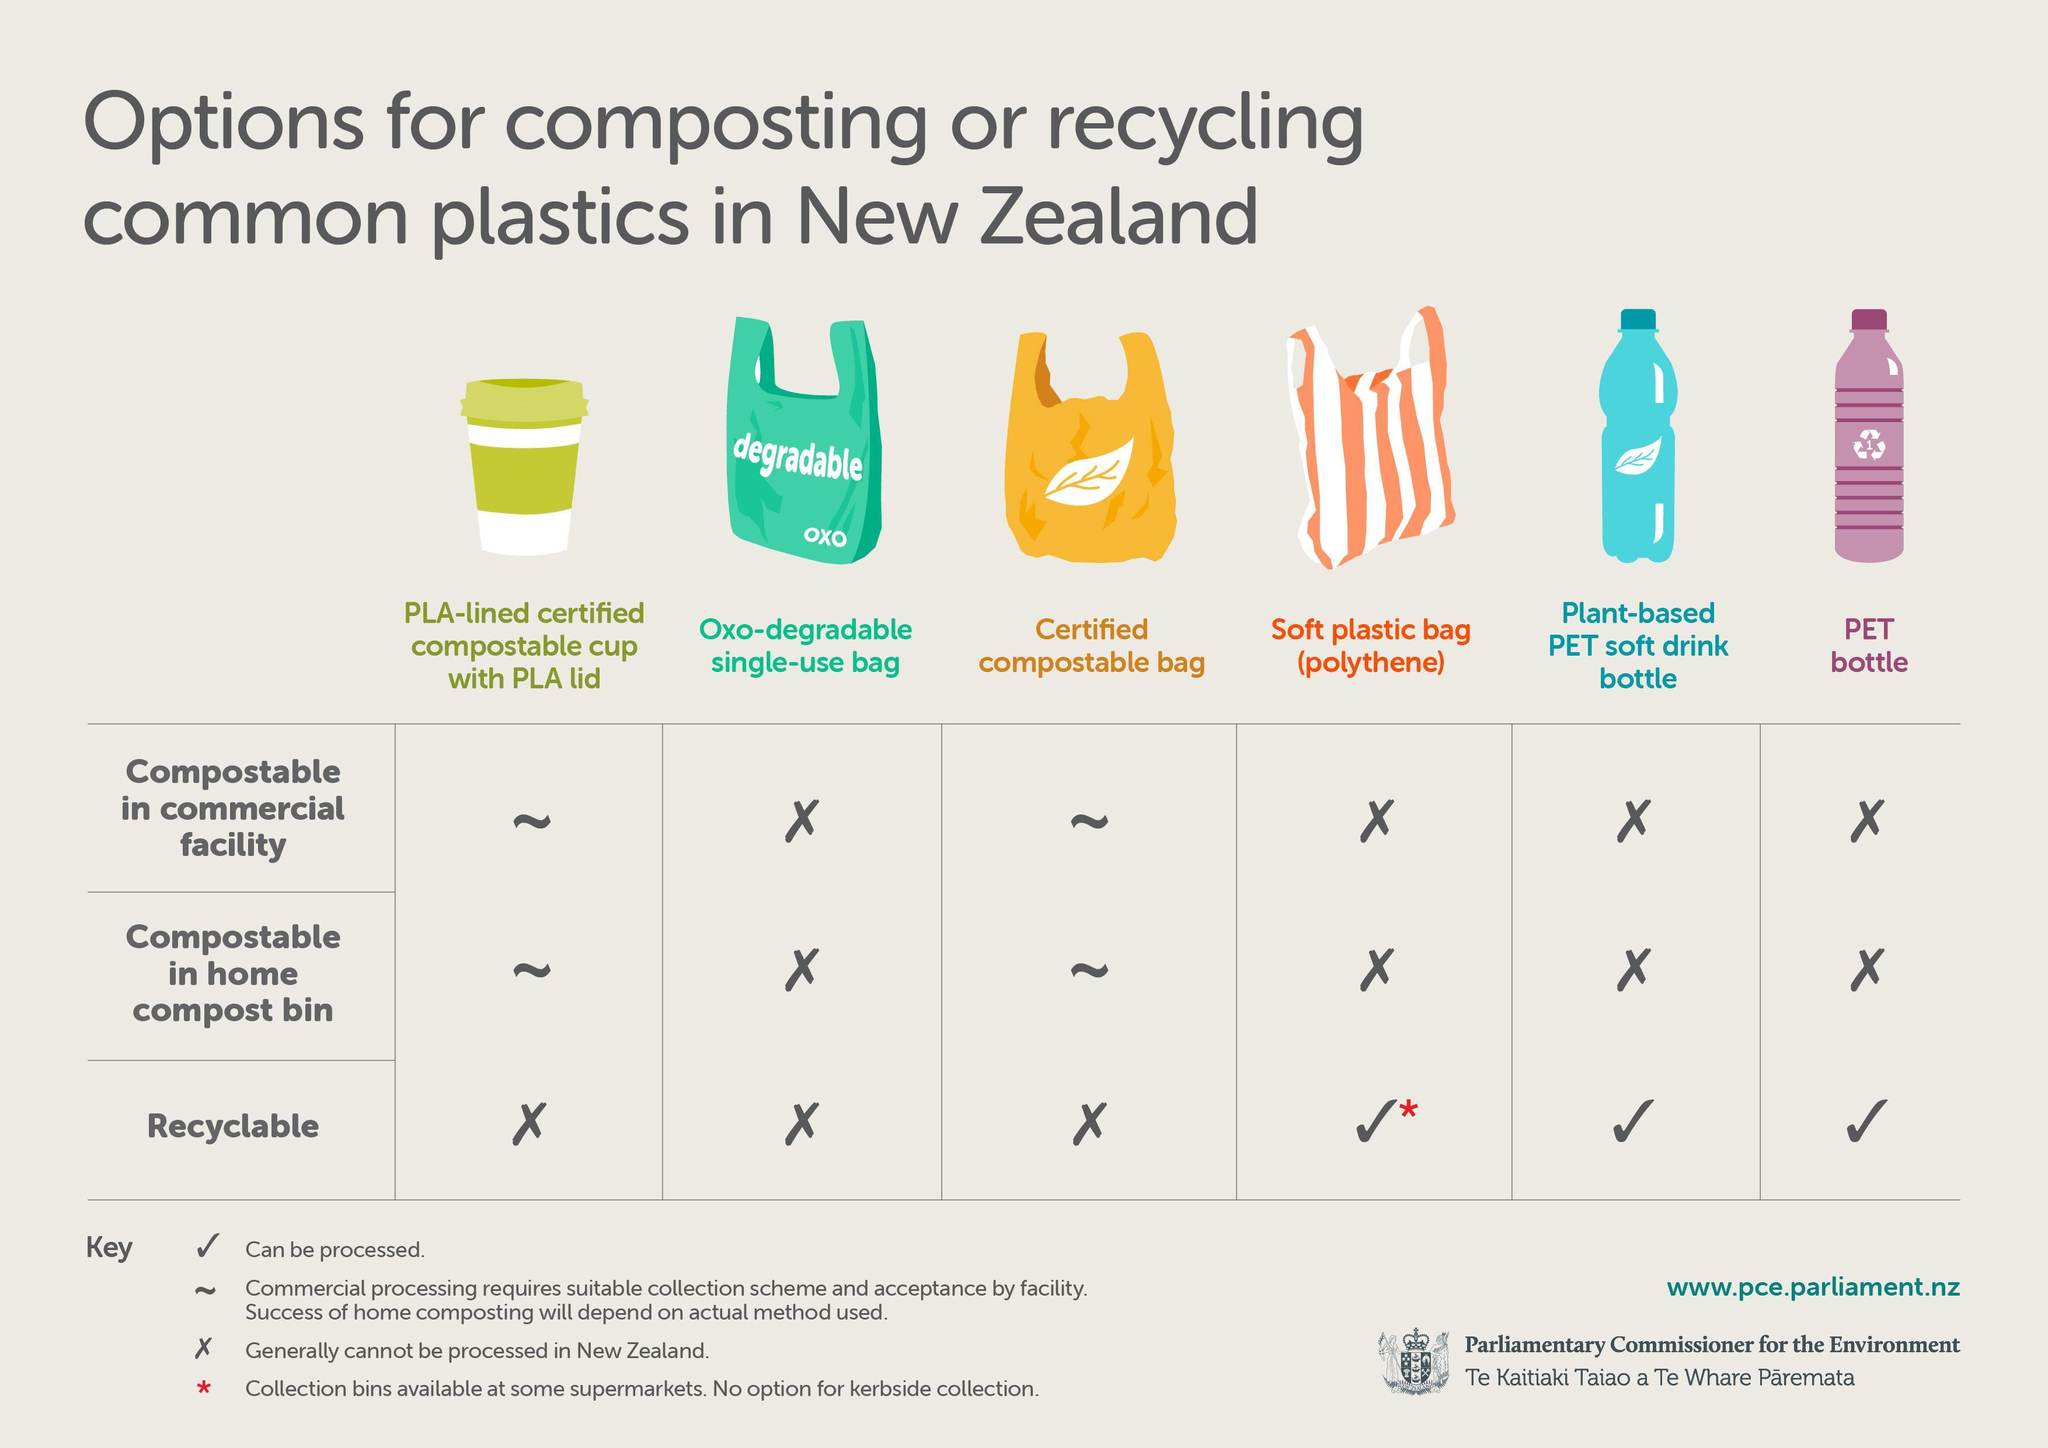How many types of plastics are shown here?
Answer the question with a short phrase. 6 Which of these bags is neither compostable nor recyclable? Oxo-degradable single-use bag How many images of plastic cups are shown here? 1 How many table keys are mentioned here? 4 What does the image of the leaf on the plastic container indicate - polythene, plant-based or PET? Plant-based How many images of plastic bags are shown here? 3 Mention the two places where plastics can be composted? Commercial facility, home compost bin What are the two things written on the green plastic bag? Degradable, oxo How many images of plastic bottles are shown here? 2 What is a soft plastic bag made of? Polythene Which of the bags can be recycled? Soft plastic bag (polythene), plant-based PET soft drink bottle, PET bottle For which of the bags, are collection bins available at some supermarkets? Soft plastic bag 